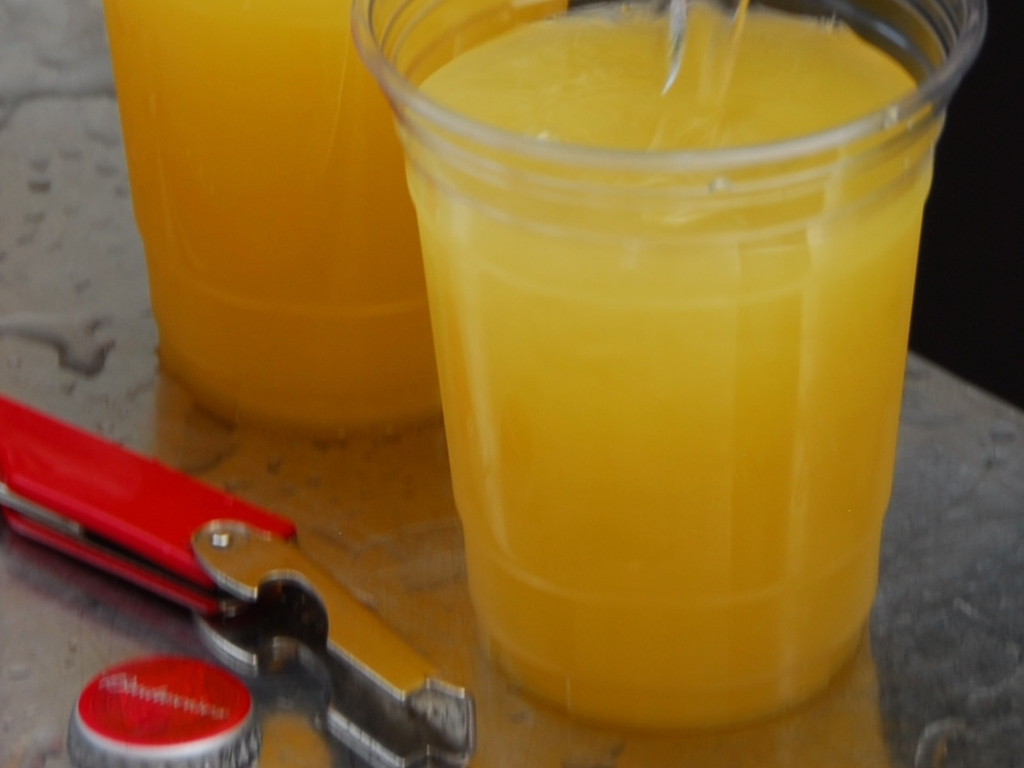Is the quality of this image excellent? The image quality is not excellent. It appears to be slightly blurry and lacking in sharpness, which suggests that the details are not as clear and vivid as they could be with a higher quality capture. 